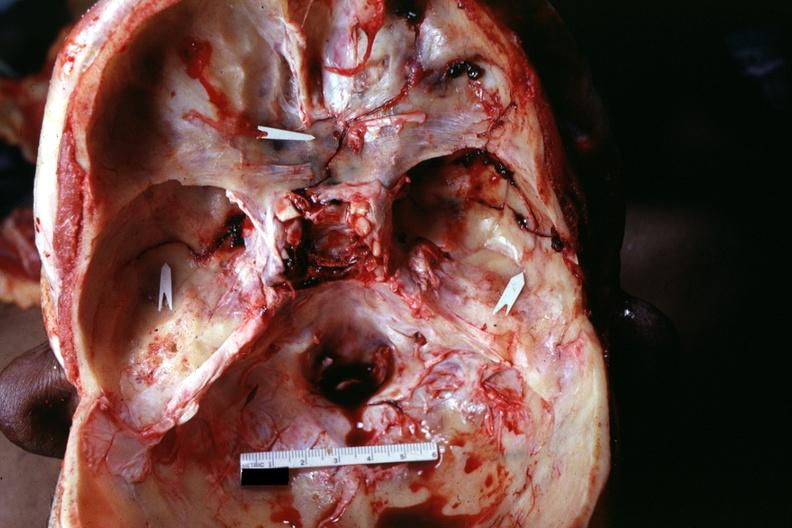what does this image show?
Answer the question using a single word or phrase. Multiple fractures very well 